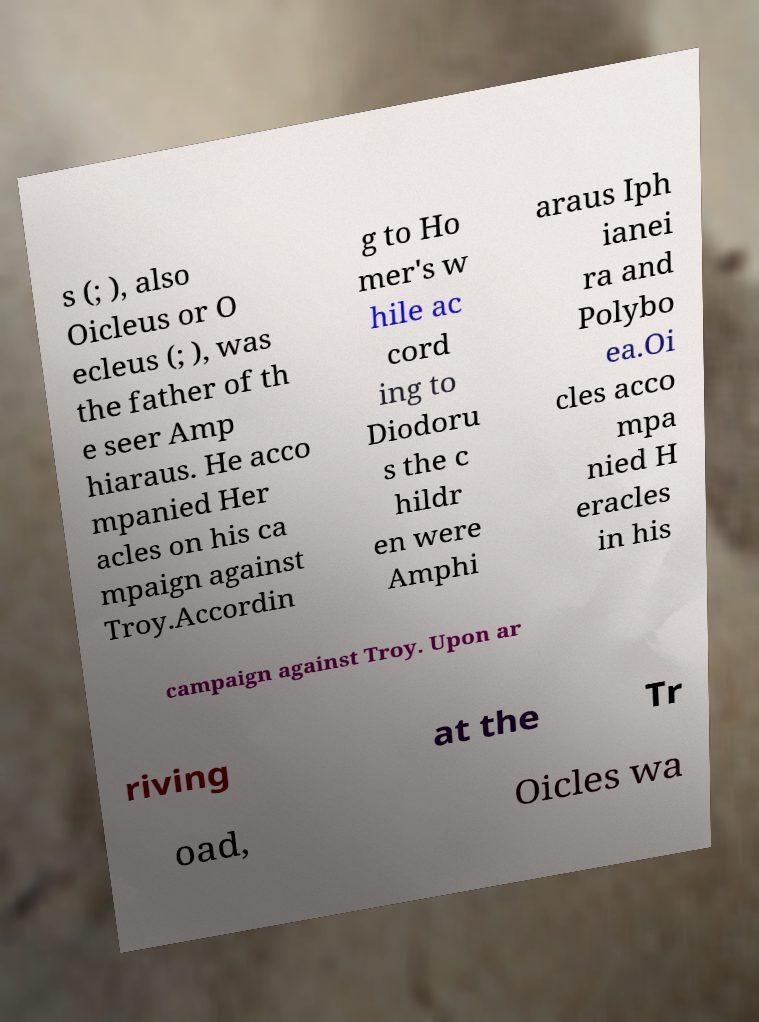Please identify and transcribe the text found in this image. s (; ), also Oicleus or O ecleus (; ), was the father of th e seer Amp hiaraus. He acco mpanied Her acles on his ca mpaign against Troy.Accordin g to Ho mer's w hile ac cord ing to Diodoru s the c hildr en were Amphi araus Iph ianei ra and Polybo ea.Oi cles acco mpa nied H eracles in his campaign against Troy. Upon ar riving at the Tr oad, Oicles wa 